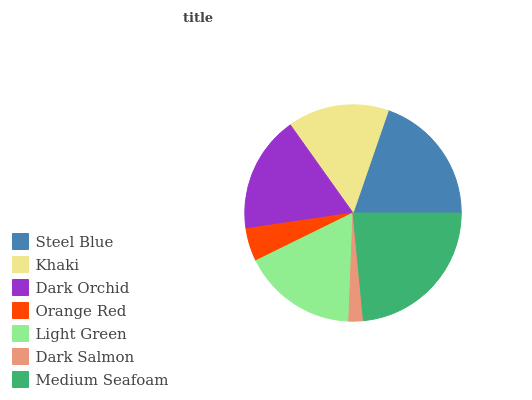Is Dark Salmon the minimum?
Answer yes or no. Yes. Is Medium Seafoam the maximum?
Answer yes or no. Yes. Is Khaki the minimum?
Answer yes or no. No. Is Khaki the maximum?
Answer yes or no. No. Is Steel Blue greater than Khaki?
Answer yes or no. Yes. Is Khaki less than Steel Blue?
Answer yes or no. Yes. Is Khaki greater than Steel Blue?
Answer yes or no. No. Is Steel Blue less than Khaki?
Answer yes or no. No. Is Light Green the high median?
Answer yes or no. Yes. Is Light Green the low median?
Answer yes or no. Yes. Is Dark Salmon the high median?
Answer yes or no. No. Is Khaki the low median?
Answer yes or no. No. 